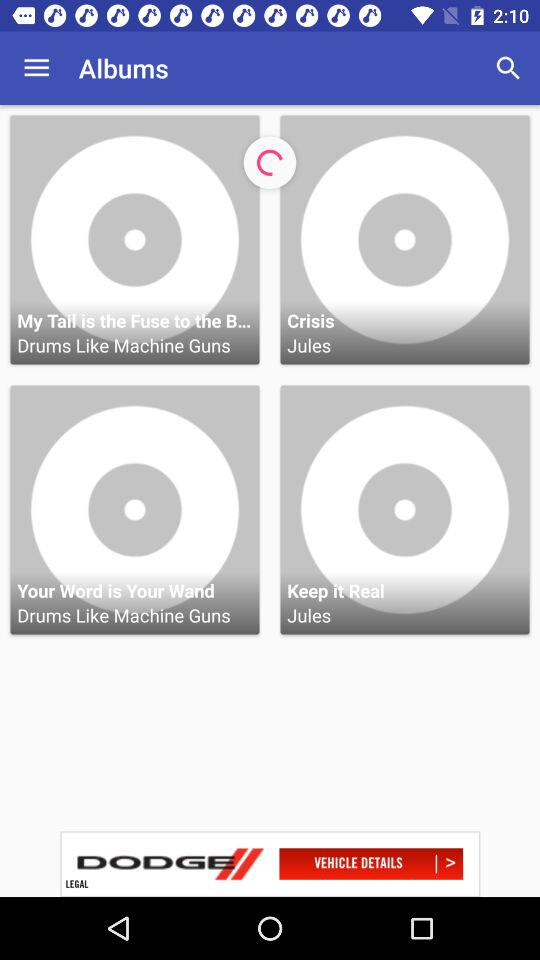What are the different available albums? The different available albums are "My Tail is the Fuse to the B...", "Crisis", "Your Word is Your Wand" and "Keep it Real". 